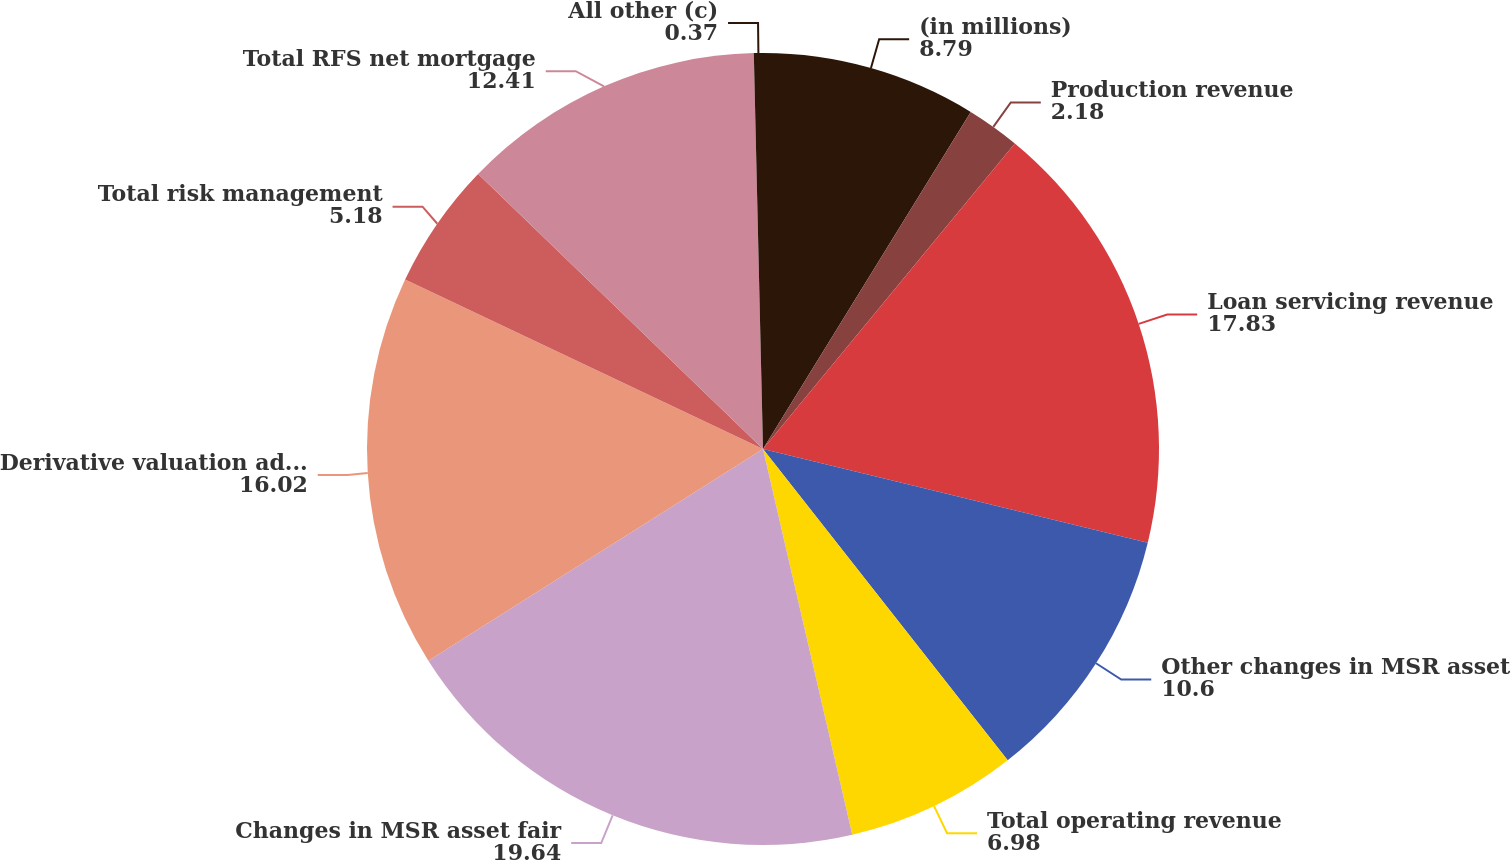Convert chart. <chart><loc_0><loc_0><loc_500><loc_500><pie_chart><fcel>(in millions)<fcel>Production revenue<fcel>Loan servicing revenue<fcel>Other changes in MSR asset<fcel>Total operating revenue<fcel>Changes in MSR asset fair<fcel>Derivative valuation adjust-<fcel>Total risk management<fcel>Total RFS net mortgage<fcel>All other (c)<nl><fcel>8.79%<fcel>2.18%<fcel>17.83%<fcel>10.6%<fcel>6.98%<fcel>19.64%<fcel>16.02%<fcel>5.18%<fcel>12.41%<fcel>0.37%<nl></chart> 